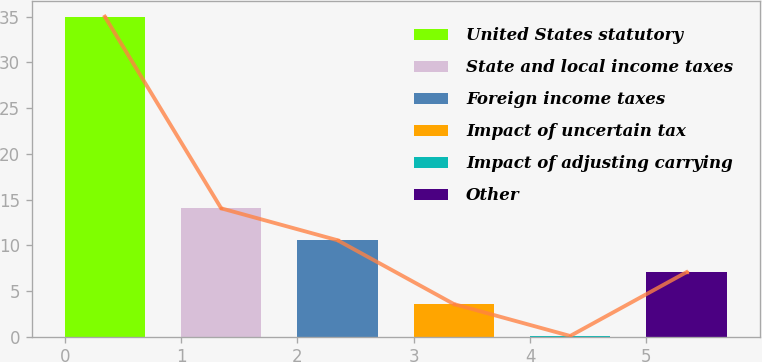<chart> <loc_0><loc_0><loc_500><loc_500><bar_chart><fcel>United States statutory<fcel>State and local income taxes<fcel>Foreign income taxes<fcel>Impact of uncertain tax<fcel>Impact of adjusting carrying<fcel>Other<nl><fcel>35<fcel>14.04<fcel>10.55<fcel>3.57<fcel>0.08<fcel>7.06<nl></chart> 